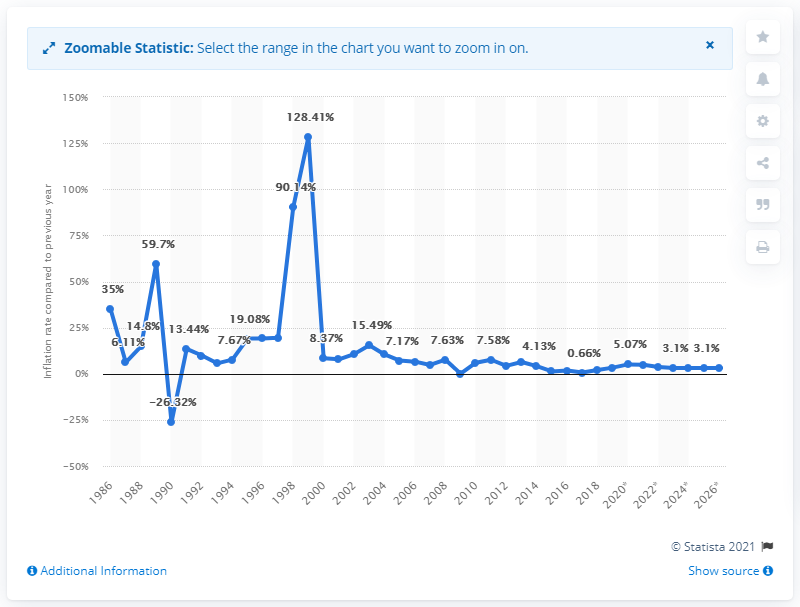Draw attention to some important aspects in this diagram. In 2019, the inflation rate in Laos was 3.32%. 